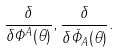Convert formula to latex. <formula><loc_0><loc_0><loc_500><loc_500>\frac { \delta } { \delta \Phi ^ { A } ( \theta ) } , \frac { \delta } { \delta \bar { \Phi } _ { A } ( \theta ) } .</formula> 